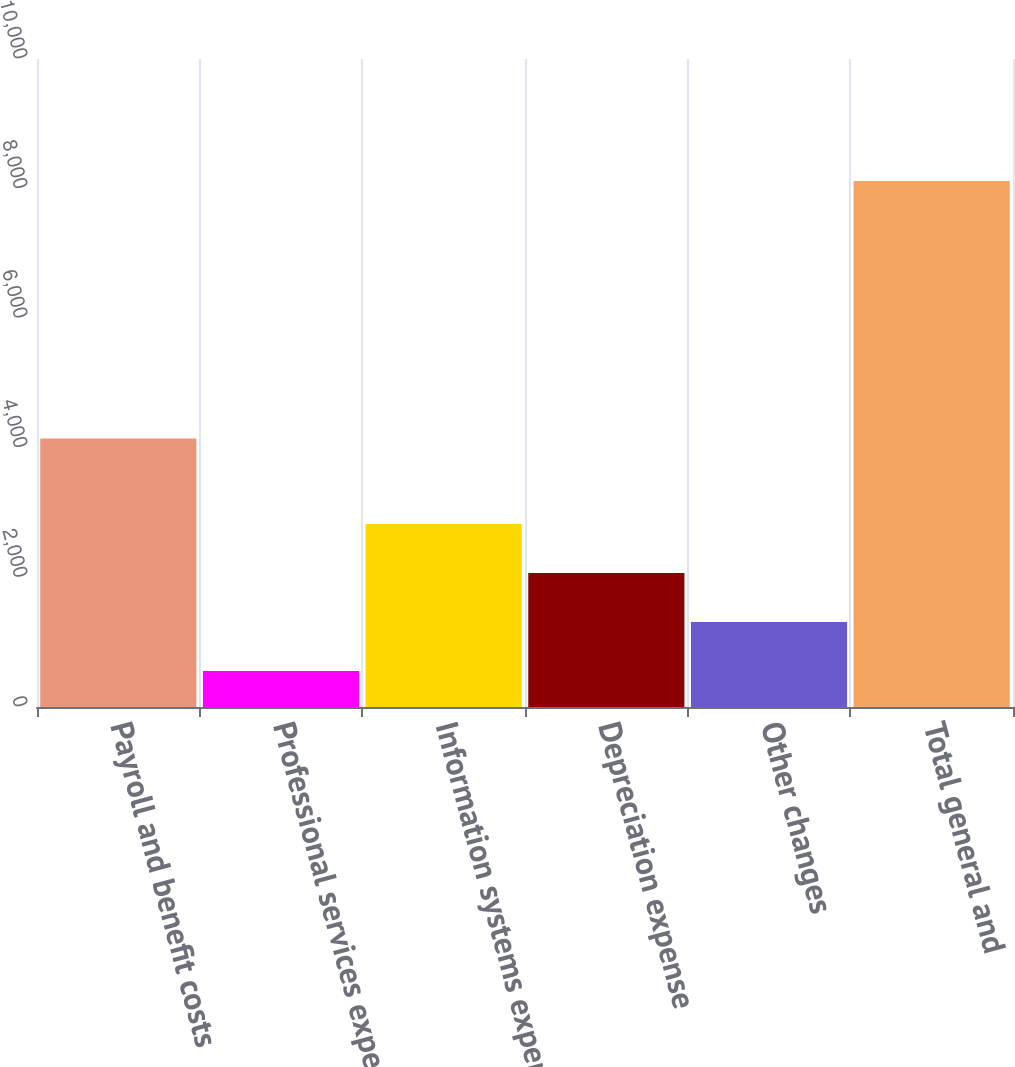Convert chart to OTSL. <chart><loc_0><loc_0><loc_500><loc_500><bar_chart><fcel>Payroll and benefit costs<fcel>Professional services expenses<fcel>Information systems expenses<fcel>Depreciation expense<fcel>Other changes<fcel>Total general and<nl><fcel>4142<fcel>557<fcel>2824.7<fcel>2068.8<fcel>1312.9<fcel>8116<nl></chart> 